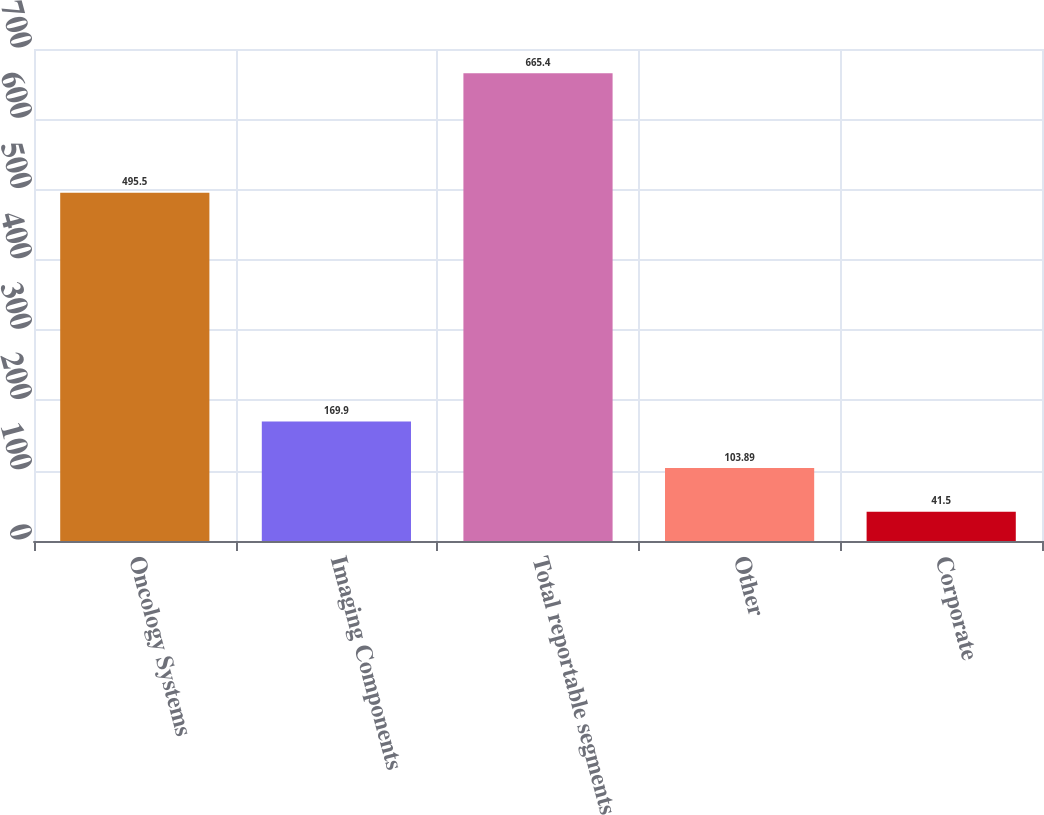Convert chart. <chart><loc_0><loc_0><loc_500><loc_500><bar_chart><fcel>Oncology Systems<fcel>Imaging Components<fcel>Total reportable segments<fcel>Other<fcel>Corporate<nl><fcel>495.5<fcel>169.9<fcel>665.4<fcel>103.89<fcel>41.5<nl></chart> 